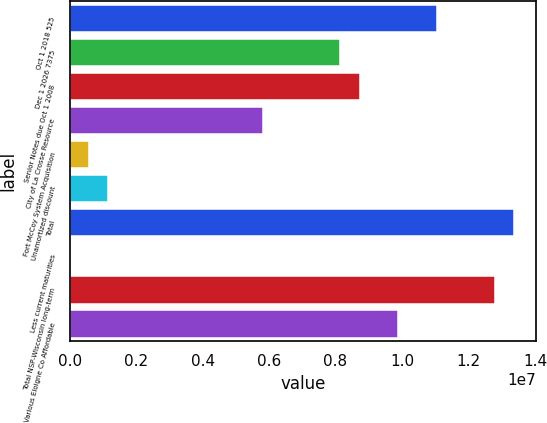<chart> <loc_0><loc_0><loc_500><loc_500><bar_chart><fcel>Oct 1 2018 525<fcel>Dec 1 2026 7375<fcel>Senior Notes due Oct 1 2008<fcel>City of La Crosse Resource<fcel>Fort McCoy System Acquisition<fcel>Unamortized discount<fcel>Total<fcel>Less current maturities<fcel>Total NSP-Wisconsin long-term<fcel>Various Eloigne Co Affordable<nl><fcel>1.10519e+07<fcel>8.14354e+06<fcel>8.72522e+06<fcel>5.81682e+06<fcel>581713<fcel>1.16339e+06<fcel>1.33786e+07<fcel>34<fcel>1.2797e+07<fcel>9.88857e+06<nl></chart> 